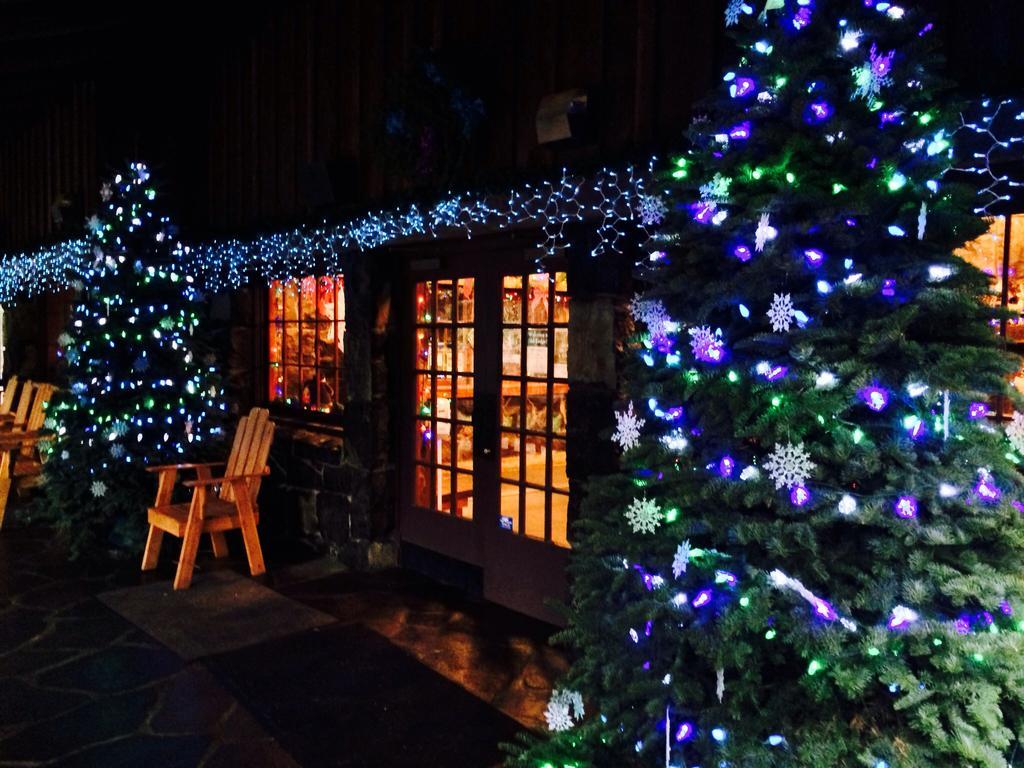In one or two sentences, can you explain what this image depicts? In this picture we can see a house in nicely decorated with a colourful lights. These are windows. We can see chairs here. Near to the house we can see two christmas trees ,which are decorated very beautifully with lights. 